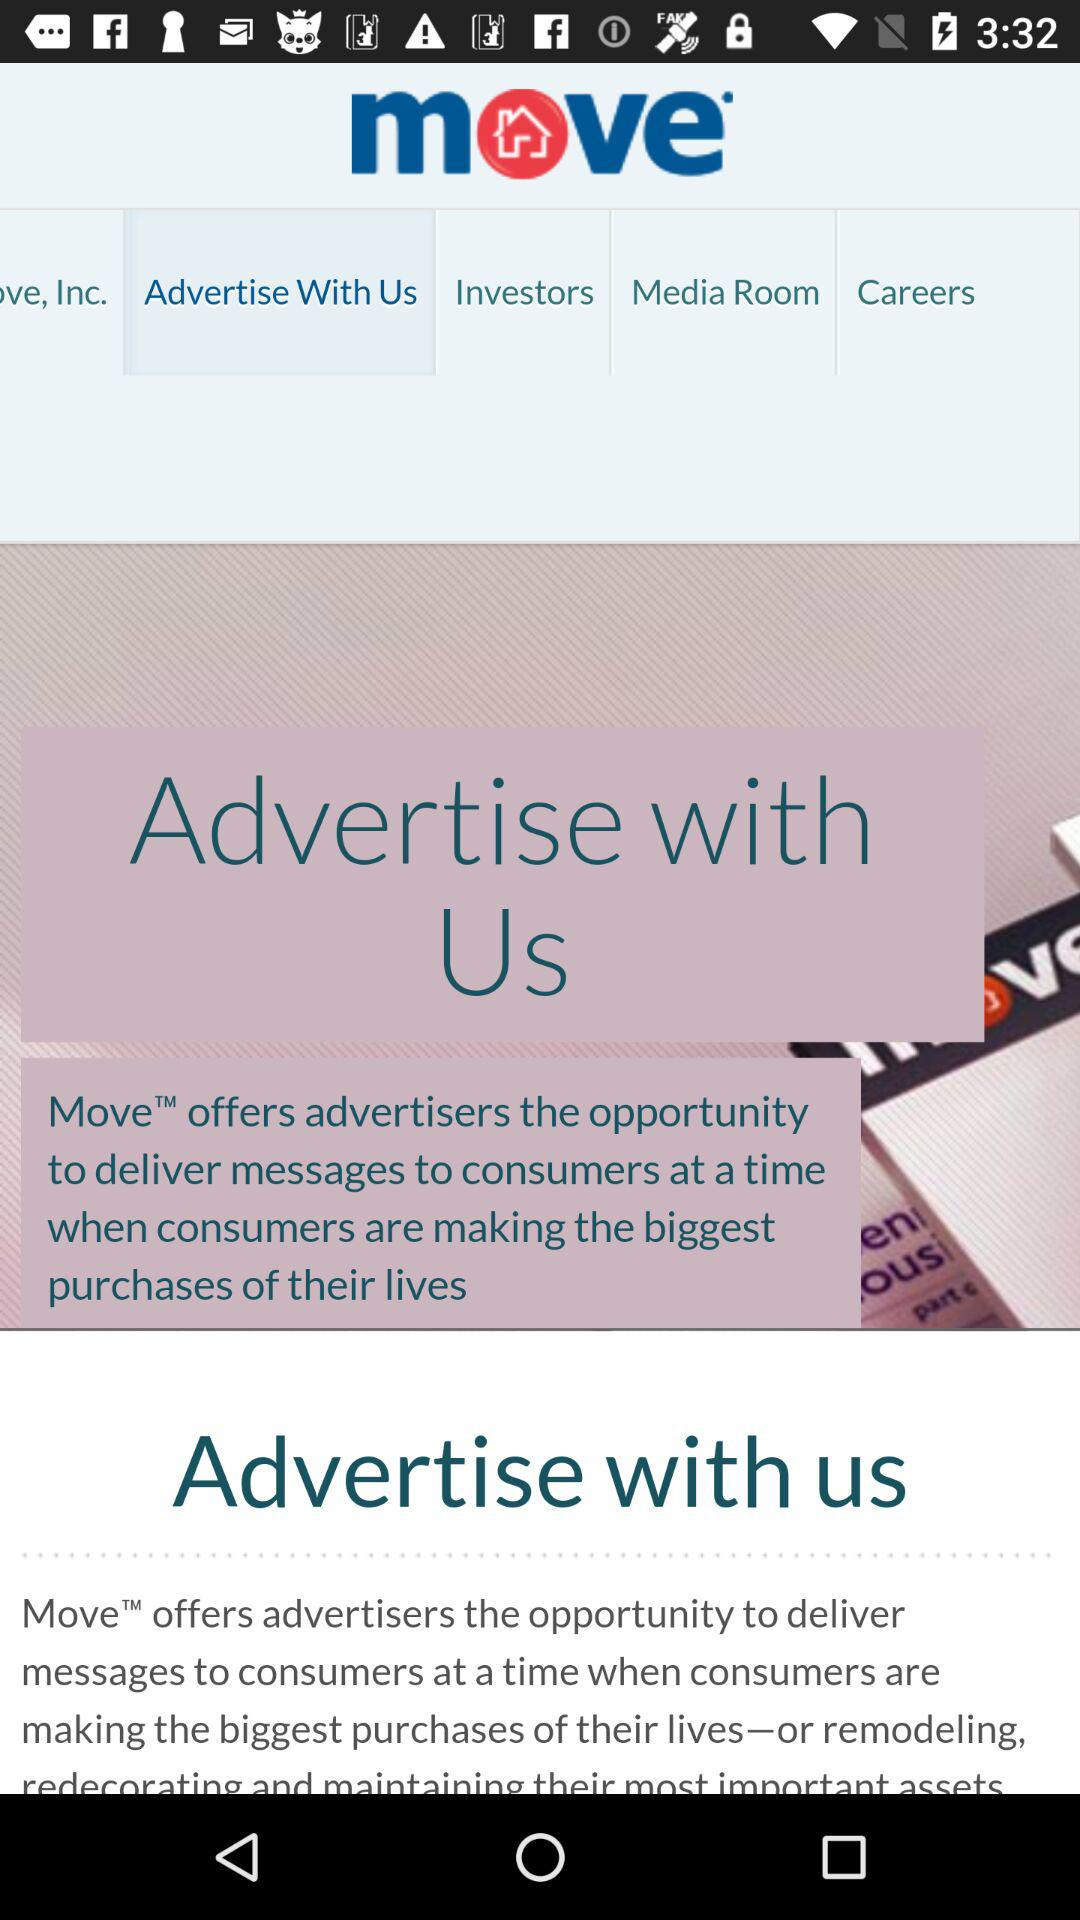What is the app name? The app name is "Move". 